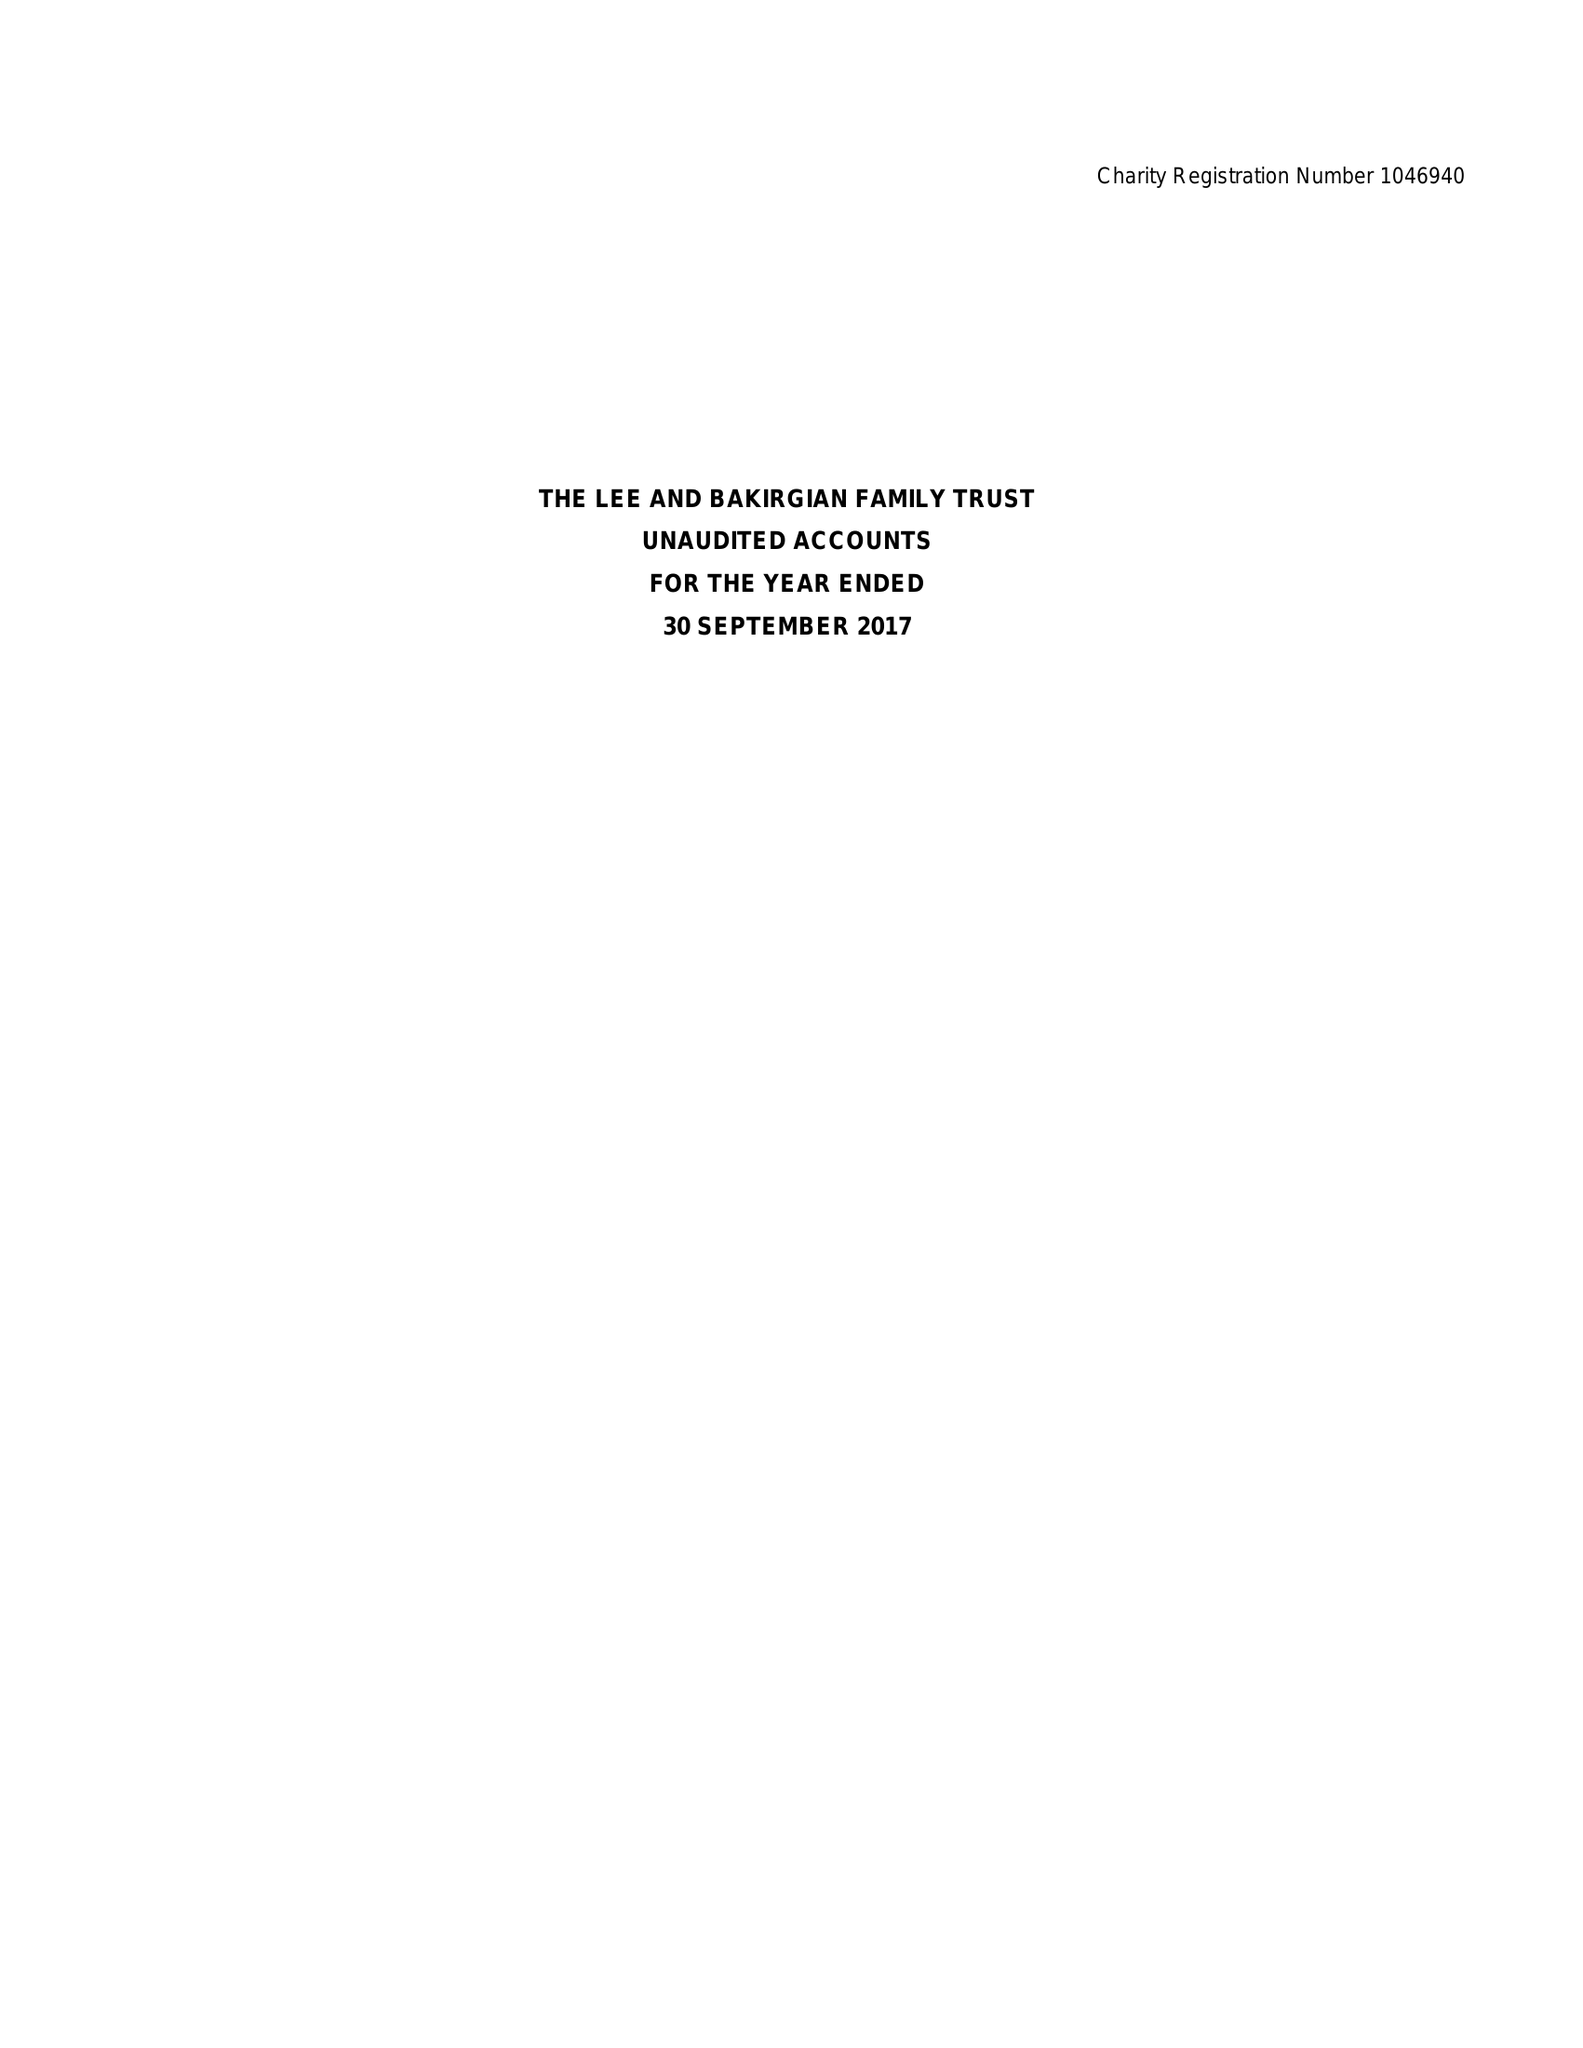What is the value for the report_date?
Answer the question using a single word or phrase. 2017-09-30 